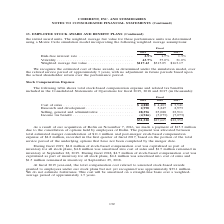According to Coherent's financial document, What was the amount of Research and development in 2019? According to the financial document, 2,990 (in thousands). The relevant text states: "4,880 $ 4,403 $ 3,541 Research and development . 2,990 3,247 2,973 Selling, general and administrative . 28,596 25,088 23,911 Income tax benefit . (4,946)..." Also, What was the amount of income tax benefit in 2018? According to the financial document, (5,073) (in thousands). The relevant text states: "28,596 25,088 23,911 Income tax benefit . (4,946) (5,073) (7,073)..." Also, In which years was cost of sales calculated? The document contains multiple relevant values: 2019, 2018, 2017. From the document: "Fiscal 2019 2018 2017 Fiscal 2019 2018 2017 Fiscal 2019 2018 2017..." Additionally, In which year was the amount of Research and development largest? According to the financial document, 2018. The relevant text states: "Fiscal 2019 2018 2017..." Also, can you calculate: What was the change in  Research and development in 2019 from 2018? Based on the calculation: 2,990-3,247, the result is -257 (in thousands). This is based on the information: "$ 4,403 $ 3,541 Research and development . 2,990 3,247 2,973 Selling, general and administrative . 28,596 25,088 23,911 Income tax benefit . (4,946) (5,07 4,880 $ 4,403 $ 3,541 Research and developmen..." The key data points involved are: 2,990, 3,247. Also, can you calculate: What was the percentage change in Research and development in 2019 from 2018? To answer this question, I need to perform calculations using the financial data. The calculation is: (2,990-3,247)/3,247, which equals -7.91 (percentage). This is based on the information: "$ 4,403 $ 3,541 Research and development . 2,990 3,247 2,973 Selling, general and administrative . 28,596 25,088 23,911 Income tax benefit . (4,946) (5,07 4,880 $ 4,403 $ 3,541 Research and developmen..." The key data points involved are: 2,990, 3,247. 